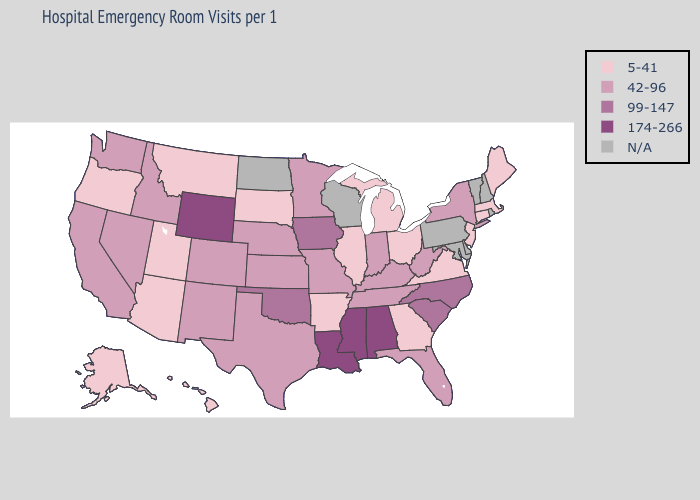Does Indiana have the lowest value in the USA?
Concise answer only. No. Which states hav the highest value in the Northeast?
Short answer required. New York. Which states have the highest value in the USA?
Answer briefly. Alabama, Louisiana, Mississippi, Wyoming. Does Indiana have the highest value in the MidWest?
Concise answer only. No. Among the states that border Washington , which have the lowest value?
Write a very short answer. Oregon. Name the states that have a value in the range 174-266?
Give a very brief answer. Alabama, Louisiana, Mississippi, Wyoming. Name the states that have a value in the range 5-41?
Be succinct. Alaska, Arizona, Arkansas, Connecticut, Georgia, Hawaii, Illinois, Maine, Massachusetts, Michigan, Montana, New Jersey, Ohio, Oregon, South Dakota, Utah, Virginia. Name the states that have a value in the range N/A?
Write a very short answer. Delaware, Maryland, New Hampshire, North Dakota, Pennsylvania, Rhode Island, Vermont, Wisconsin. Is the legend a continuous bar?
Give a very brief answer. No. Among the states that border North Dakota , which have the lowest value?
Write a very short answer. Montana, South Dakota. Name the states that have a value in the range 5-41?
Be succinct. Alaska, Arizona, Arkansas, Connecticut, Georgia, Hawaii, Illinois, Maine, Massachusetts, Michigan, Montana, New Jersey, Ohio, Oregon, South Dakota, Utah, Virginia. What is the value of Illinois?
Be succinct. 5-41. Name the states that have a value in the range 174-266?
Be succinct. Alabama, Louisiana, Mississippi, Wyoming. How many symbols are there in the legend?
Give a very brief answer. 5. Does New Jersey have the lowest value in the Northeast?
Quick response, please. Yes. 